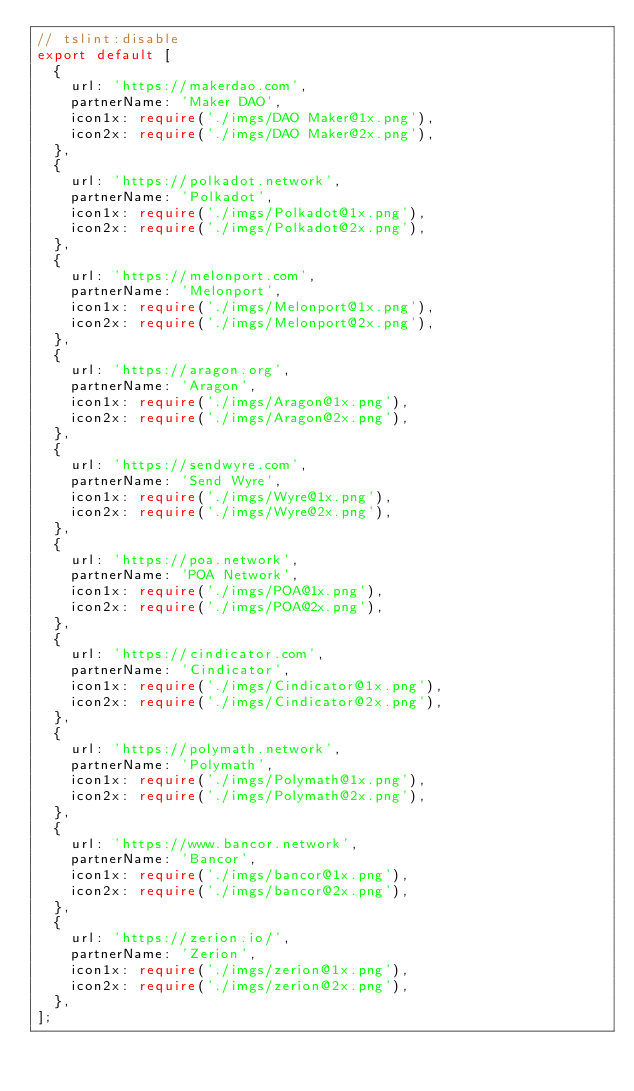<code> <loc_0><loc_0><loc_500><loc_500><_TypeScript_>// tslint:disable
export default [
  {
    url: 'https://makerdao.com',
    partnerName: 'Maker DAO',
    icon1x: require('./imgs/DAO Maker@1x.png'),
    icon2x: require('./imgs/DAO Maker@2x.png'),
  },
  {
    url: 'https://polkadot.network',
    partnerName: 'Polkadot',
    icon1x: require('./imgs/Polkadot@1x.png'),
    icon2x: require('./imgs/Polkadot@2x.png'),
  },
  {
    url: 'https://melonport.com',
    partnerName: 'Melonport',
    icon1x: require('./imgs/Melonport@1x.png'),
    icon2x: require('./imgs/Melonport@2x.png'),
  },
  {
    url: 'https://aragon.org',
    partnerName: 'Aragon',
    icon1x: require('./imgs/Aragon@1x.png'),
    icon2x: require('./imgs/Aragon@2x.png'),
  },
  {
    url: 'https://sendwyre.com',
    partnerName: 'Send Wyre',
    icon1x: require('./imgs/Wyre@1x.png'),
    icon2x: require('./imgs/Wyre@2x.png'),
  },
  {
    url: 'https://poa.network',
    partnerName: 'POA Network',
    icon1x: require('./imgs/POA@1x.png'),
    icon2x: require('./imgs/POA@2x.png'),
  },
  {
    url: 'https://cindicator.com',
    partnerName: 'Cindicator',
    icon1x: require('./imgs/Cindicator@1x.png'),
    icon2x: require('./imgs/Cindicator@2x.png'),
  },
  {
    url: 'https://polymath.network',
    partnerName: 'Polymath',
    icon1x: require('./imgs/Polymath@1x.png'),
    icon2x: require('./imgs/Polymath@2x.png'),
  },
  {
    url: 'https://www.bancor.network',
    partnerName: 'Bancor',
    icon1x: require('./imgs/bancor@1x.png'),
    icon2x: require('./imgs/bancor@2x.png'),
  },
  {
    url: 'https://zerion.io/',
    partnerName: 'Zerion',
    icon1x: require('./imgs/zerion@1x.png'),
    icon2x: require('./imgs/zerion@2x.png'),
  },
];
</code> 